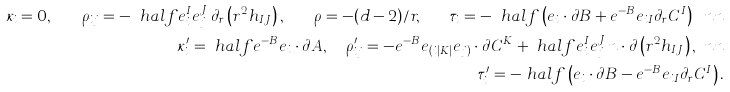<formula> <loc_0><loc_0><loc_500><loc_500>\kappa _ { i } = 0 , \quad \rho _ { i j } = - \ h a l f e _ { i } ^ { I } e _ { j } ^ { J } \, \partial _ { r } \left ( r ^ { 2 } h _ { I J } \right ) , \quad \rho = - ( d - 2 ) / r , \quad \tau _ { i } = - \ h a l f \left ( e _ { i } \cdot \partial B + e ^ { - B } e _ { i I } \partial _ { r } C ^ { I } \right ) \ n n \\ \kappa ^ { \prime } _ { i } = \ h a l f e ^ { - B } e _ { i } \cdot \partial A , \quad \rho ^ { \prime } _ { i j } = - e ^ { - B } e _ { ( i | K | } e _ { j ) } \cdot \partial C ^ { K } + \ h a l f e _ { i } ^ { I } e _ { j } ^ { J } \, n \cdot \partial \left ( r ^ { 2 } h _ { I J } \right ) , \ n n \\ \tau ^ { \prime } _ { i } = - \ h a l f \left ( e _ { i } \cdot \partial B - e ^ { - B } e _ { i I } \partial _ { r } C ^ { I } \right ) .</formula> 